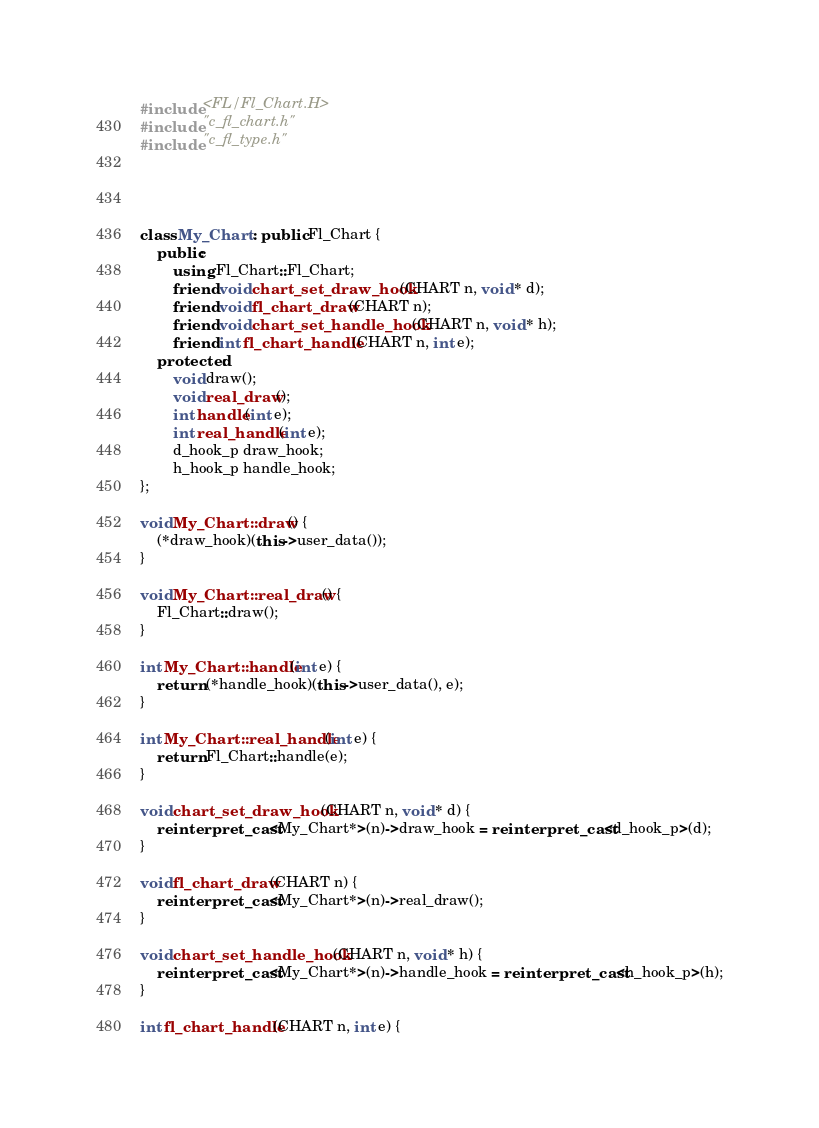<code> <loc_0><loc_0><loc_500><loc_500><_C++_>

#include <FL/Fl_Chart.H>
#include "c_fl_chart.h"
#include "c_fl_type.h"




class My_Chart : public Fl_Chart {
    public:
        using Fl_Chart::Fl_Chart;
        friend void chart_set_draw_hook(CHART n, void * d);
        friend void fl_chart_draw(CHART n);
        friend void chart_set_handle_hook(CHART n, void * h);
        friend int fl_chart_handle(CHART n, int e);
    protected:
        void draw();
        void real_draw();
        int handle(int e);
        int real_handle(int e);
        d_hook_p draw_hook;
        h_hook_p handle_hook;
};

void My_Chart::draw() {
    (*draw_hook)(this->user_data());
}

void My_Chart::real_draw() {
    Fl_Chart::draw();
}

int My_Chart::handle(int e) {
    return (*handle_hook)(this->user_data(), e);
}

int My_Chart::real_handle(int e) {
    return Fl_Chart::handle(e);
}

void chart_set_draw_hook(CHART n, void * d) {
    reinterpret_cast<My_Chart*>(n)->draw_hook = reinterpret_cast<d_hook_p>(d);
}

void fl_chart_draw(CHART n) {
    reinterpret_cast<My_Chart*>(n)->real_draw();
}

void chart_set_handle_hook(CHART n, void * h) {
    reinterpret_cast<My_Chart*>(n)->handle_hook = reinterpret_cast<h_hook_p>(h);
}

int fl_chart_handle(CHART n, int e) {</code> 